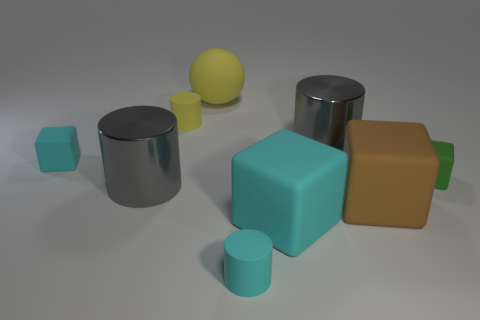Subtract 1 cylinders. How many cylinders are left? 3 Add 1 cyan things. How many objects exist? 10 Subtract all cubes. How many objects are left? 5 Subtract all small cyan blocks. Subtract all brown objects. How many objects are left? 7 Add 8 brown objects. How many brown objects are left? 9 Add 5 large cyan rubber blocks. How many large cyan rubber blocks exist? 6 Subtract 1 yellow cylinders. How many objects are left? 8 